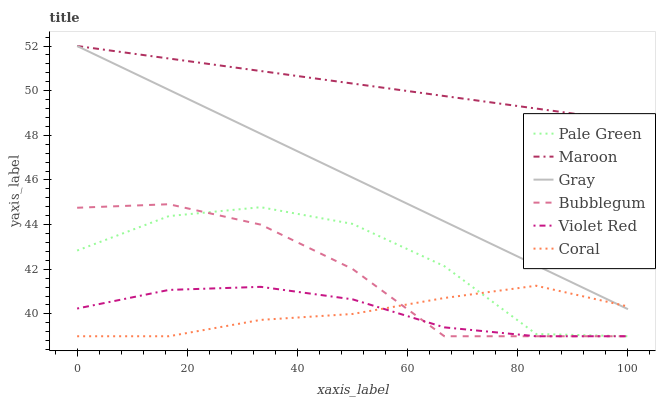Does Coral have the minimum area under the curve?
Answer yes or no. Yes. Does Maroon have the maximum area under the curve?
Answer yes or no. Yes. Does Violet Red have the minimum area under the curve?
Answer yes or no. No. Does Violet Red have the maximum area under the curve?
Answer yes or no. No. Is Gray the smoothest?
Answer yes or no. Yes. Is Pale Green the roughest?
Answer yes or no. Yes. Is Violet Red the smoothest?
Answer yes or no. No. Is Violet Red the roughest?
Answer yes or no. No. Does Maroon have the lowest value?
Answer yes or no. No. Does Coral have the highest value?
Answer yes or no. No. Is Pale Green less than Gray?
Answer yes or no. Yes. Is Maroon greater than Coral?
Answer yes or no. Yes. Does Pale Green intersect Gray?
Answer yes or no. No. 